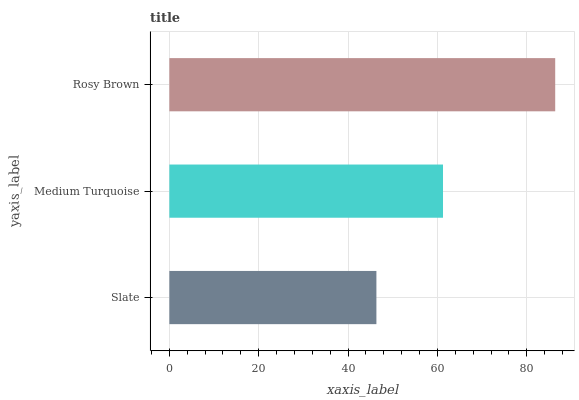Is Slate the minimum?
Answer yes or no. Yes. Is Rosy Brown the maximum?
Answer yes or no. Yes. Is Medium Turquoise the minimum?
Answer yes or no. No. Is Medium Turquoise the maximum?
Answer yes or no. No. Is Medium Turquoise greater than Slate?
Answer yes or no. Yes. Is Slate less than Medium Turquoise?
Answer yes or no. Yes. Is Slate greater than Medium Turquoise?
Answer yes or no. No. Is Medium Turquoise less than Slate?
Answer yes or no. No. Is Medium Turquoise the high median?
Answer yes or no. Yes. Is Medium Turquoise the low median?
Answer yes or no. Yes. Is Rosy Brown the high median?
Answer yes or no. No. Is Slate the low median?
Answer yes or no. No. 